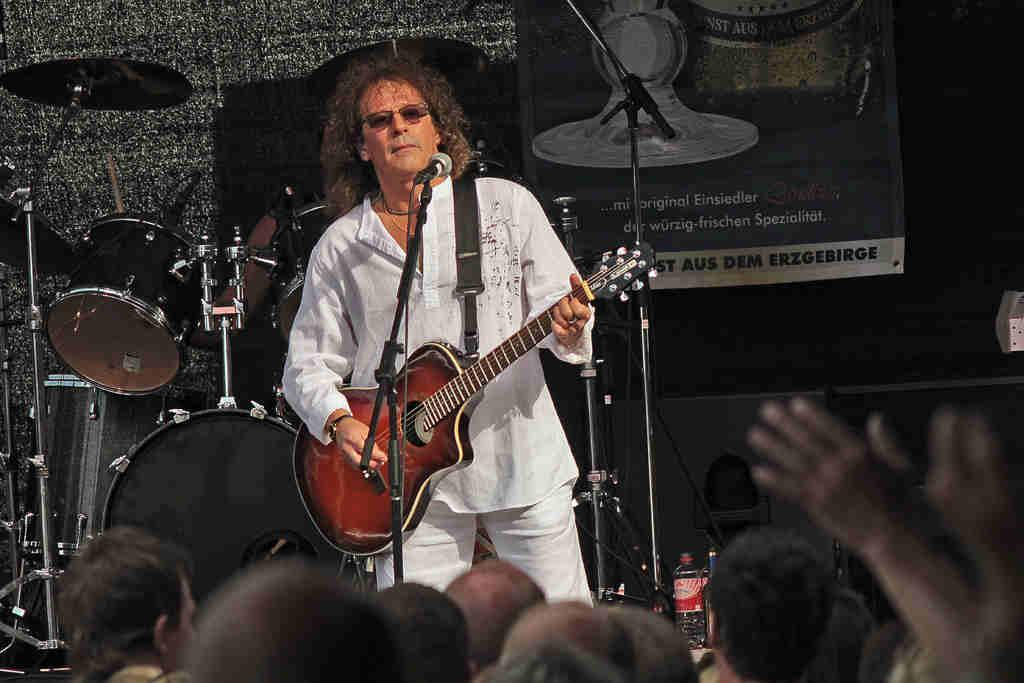What is the person in the image holding? The person is standing and holding a guitar. What else can be seen in the image related to music? There is a musical instrument and a microphone with a stand in the image. Who else is present in the image? There are people who appear to be an audience in the image. What can be seen in the background of the image? There is a banner visible in the background of the image. Can you see any horses or a trail in the image? No, there are no horses or trail visible in the image. What type of quince is being used as a prop in the image? There is no quince present in the image. 